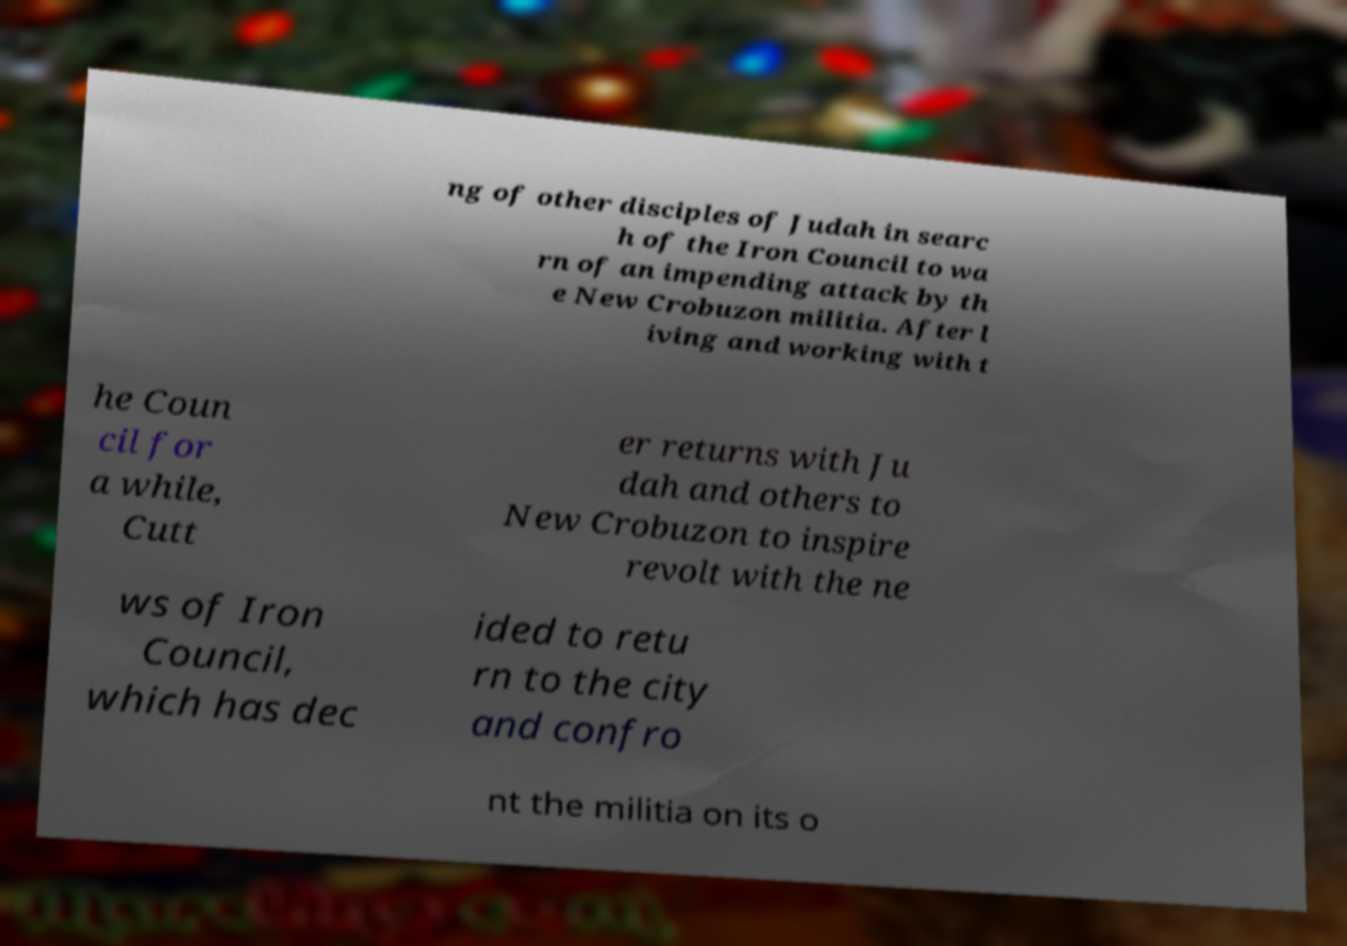Could you extract and type out the text from this image? ng of other disciples of Judah in searc h of the Iron Council to wa rn of an impending attack by th e New Crobuzon militia. After l iving and working with t he Coun cil for a while, Cutt er returns with Ju dah and others to New Crobuzon to inspire revolt with the ne ws of Iron Council, which has dec ided to retu rn to the city and confro nt the militia on its o 